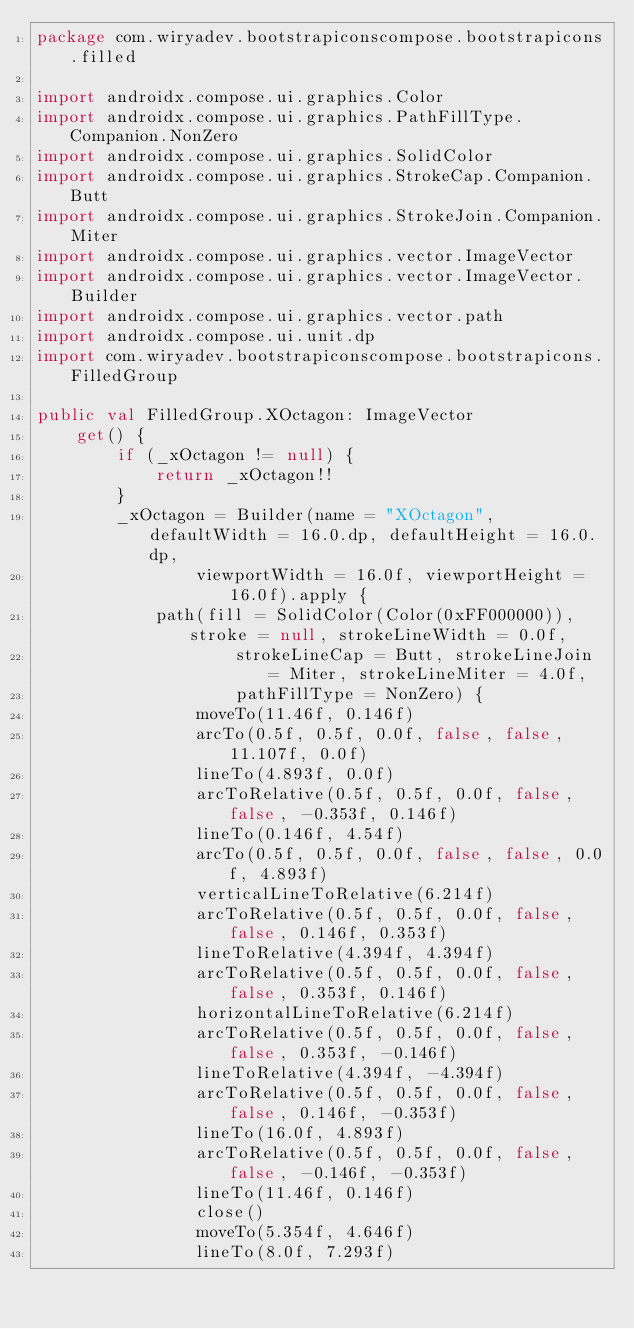<code> <loc_0><loc_0><loc_500><loc_500><_Kotlin_>package com.wiryadev.bootstrapiconscompose.bootstrapicons.filled

import androidx.compose.ui.graphics.Color
import androidx.compose.ui.graphics.PathFillType.Companion.NonZero
import androidx.compose.ui.graphics.SolidColor
import androidx.compose.ui.graphics.StrokeCap.Companion.Butt
import androidx.compose.ui.graphics.StrokeJoin.Companion.Miter
import androidx.compose.ui.graphics.vector.ImageVector
import androidx.compose.ui.graphics.vector.ImageVector.Builder
import androidx.compose.ui.graphics.vector.path
import androidx.compose.ui.unit.dp
import com.wiryadev.bootstrapiconscompose.bootstrapicons.FilledGroup

public val FilledGroup.XOctagon: ImageVector
    get() {
        if (_xOctagon != null) {
            return _xOctagon!!
        }
        _xOctagon = Builder(name = "XOctagon", defaultWidth = 16.0.dp, defaultHeight = 16.0.dp,
                viewportWidth = 16.0f, viewportHeight = 16.0f).apply {
            path(fill = SolidColor(Color(0xFF000000)), stroke = null, strokeLineWidth = 0.0f,
                    strokeLineCap = Butt, strokeLineJoin = Miter, strokeLineMiter = 4.0f,
                    pathFillType = NonZero) {
                moveTo(11.46f, 0.146f)
                arcTo(0.5f, 0.5f, 0.0f, false, false, 11.107f, 0.0f)
                lineTo(4.893f, 0.0f)
                arcToRelative(0.5f, 0.5f, 0.0f, false, false, -0.353f, 0.146f)
                lineTo(0.146f, 4.54f)
                arcTo(0.5f, 0.5f, 0.0f, false, false, 0.0f, 4.893f)
                verticalLineToRelative(6.214f)
                arcToRelative(0.5f, 0.5f, 0.0f, false, false, 0.146f, 0.353f)
                lineToRelative(4.394f, 4.394f)
                arcToRelative(0.5f, 0.5f, 0.0f, false, false, 0.353f, 0.146f)
                horizontalLineToRelative(6.214f)
                arcToRelative(0.5f, 0.5f, 0.0f, false, false, 0.353f, -0.146f)
                lineToRelative(4.394f, -4.394f)
                arcToRelative(0.5f, 0.5f, 0.0f, false, false, 0.146f, -0.353f)
                lineTo(16.0f, 4.893f)
                arcToRelative(0.5f, 0.5f, 0.0f, false, false, -0.146f, -0.353f)
                lineTo(11.46f, 0.146f)
                close()
                moveTo(5.354f, 4.646f)
                lineTo(8.0f, 7.293f)</code> 